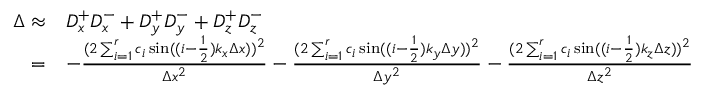Convert formula to latex. <formula><loc_0><loc_0><loc_500><loc_500>\begin{array} { r l } { \Delta \approx } & { D _ { x } ^ { + } D _ { x } ^ { - } + D _ { y } ^ { + } D _ { y } ^ { - } + D _ { z } ^ { + } D _ { z } ^ { - } } \\ { = } & { - \frac { ( 2 \sum _ { i = 1 } ^ { r } c _ { i } \sin ( ( i - \frac { 1 } { 2 } ) k _ { x } \Delta x ) ) ^ { 2 } } { \Delta x ^ { 2 } } - \frac { ( 2 \sum _ { i = 1 } ^ { r } c _ { i } \sin ( ( i - \frac { 1 } { 2 } ) k _ { y } \Delta y ) ) ^ { 2 } } { \Delta y ^ { 2 } } - \frac { ( 2 \sum _ { i = 1 } ^ { r } c _ { i } \sin ( ( i - \frac { 1 } { 2 } ) k _ { z } \Delta z ) ) ^ { 2 } } { \Delta z ^ { 2 } } } \end{array}</formula> 